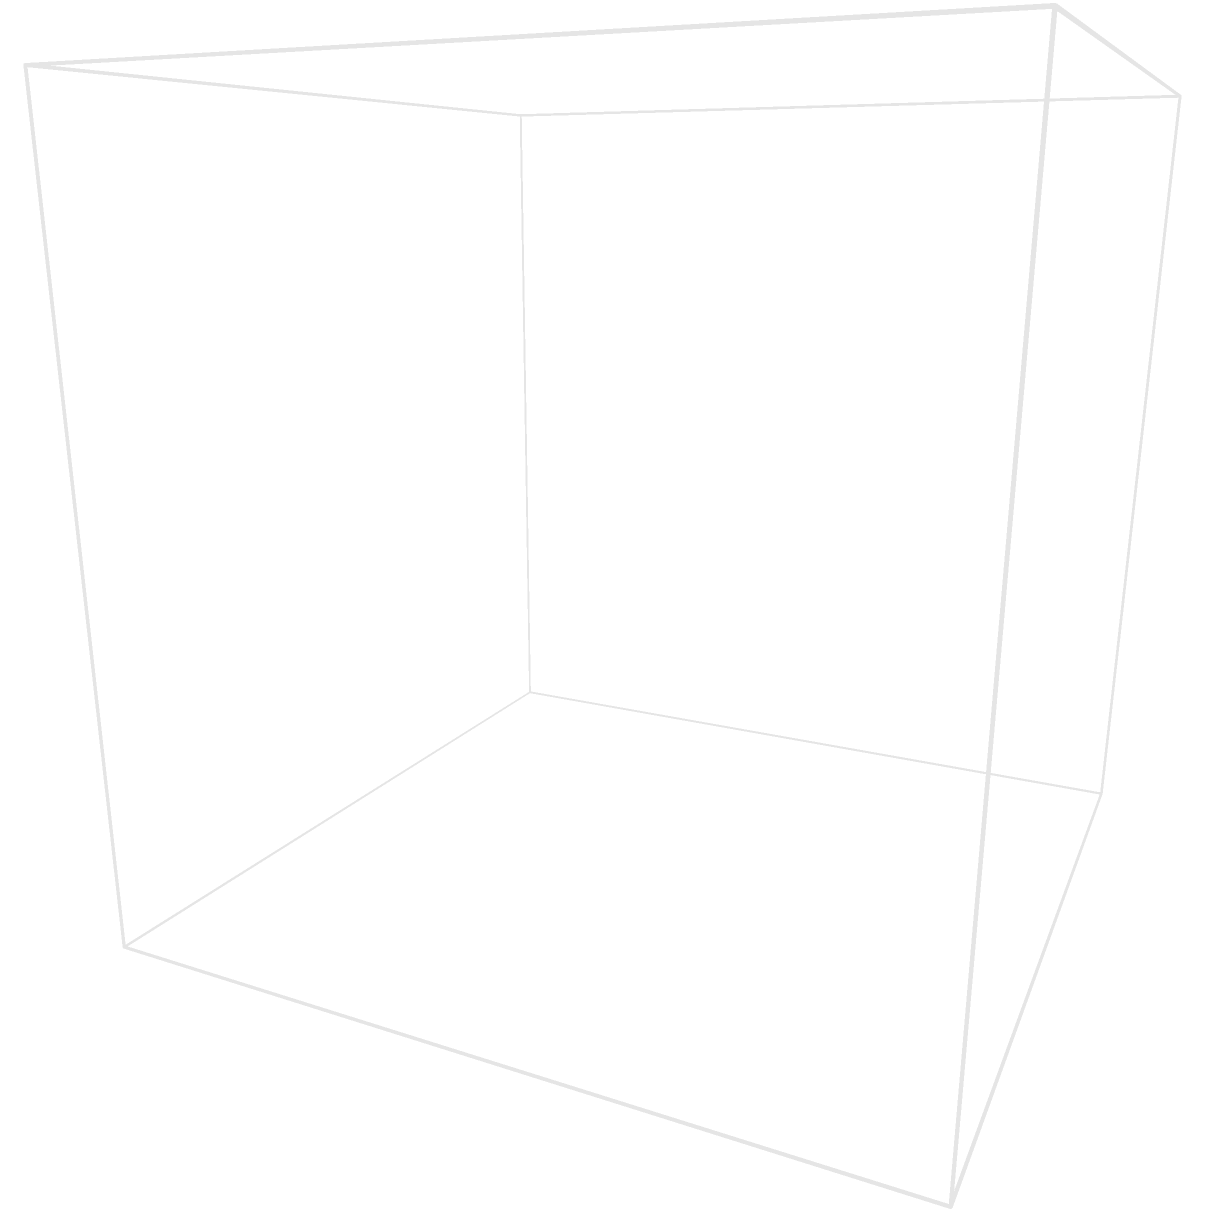In planning a cat-friendly, child-safe home office layout, you've placed a cat tree in the corner of the room. If the room dimensions are 10 feet (length) x 8 feet (width) x 8 feet (height), and the cat tree is positioned 2 feet from both adjacent walls and is 6 feet tall, what are the coordinates $(x, y, z)$ of the top of the cat tree? Let's approach this step-by-step:

1. The room's dimensions are 10 x 8 x 8 feet, with the origin (0, 0, 0) at one corner.

2. The cat tree is positioned in a corner, 2 feet from each adjacent wall. This means:
   - It's 2 feet from the back wall (y-axis)
   - It's 2 feet from the side wall (x-axis)

3. To find the x-coordinate:
   - The room is 10 feet long
   - The cat tree is 2 feet from the opposite wall
   - So, $x = 10 - 2 = 8$ feet

4. To find the y-coordinate:
   - The room is 8 feet wide
   - The cat tree is 2 feet from the side wall
   - So, $y = 8 - 2 = 6$ feet

5. To find the z-coordinate:
   - The cat tree is 6 feet tall
   - It starts from the floor (z = 0)
   - So, $z = 6$ feet

Therefore, the coordinates of the top of the cat tree are $(8, 6, 6)$.
Answer: $(8, 6, 6)$ 